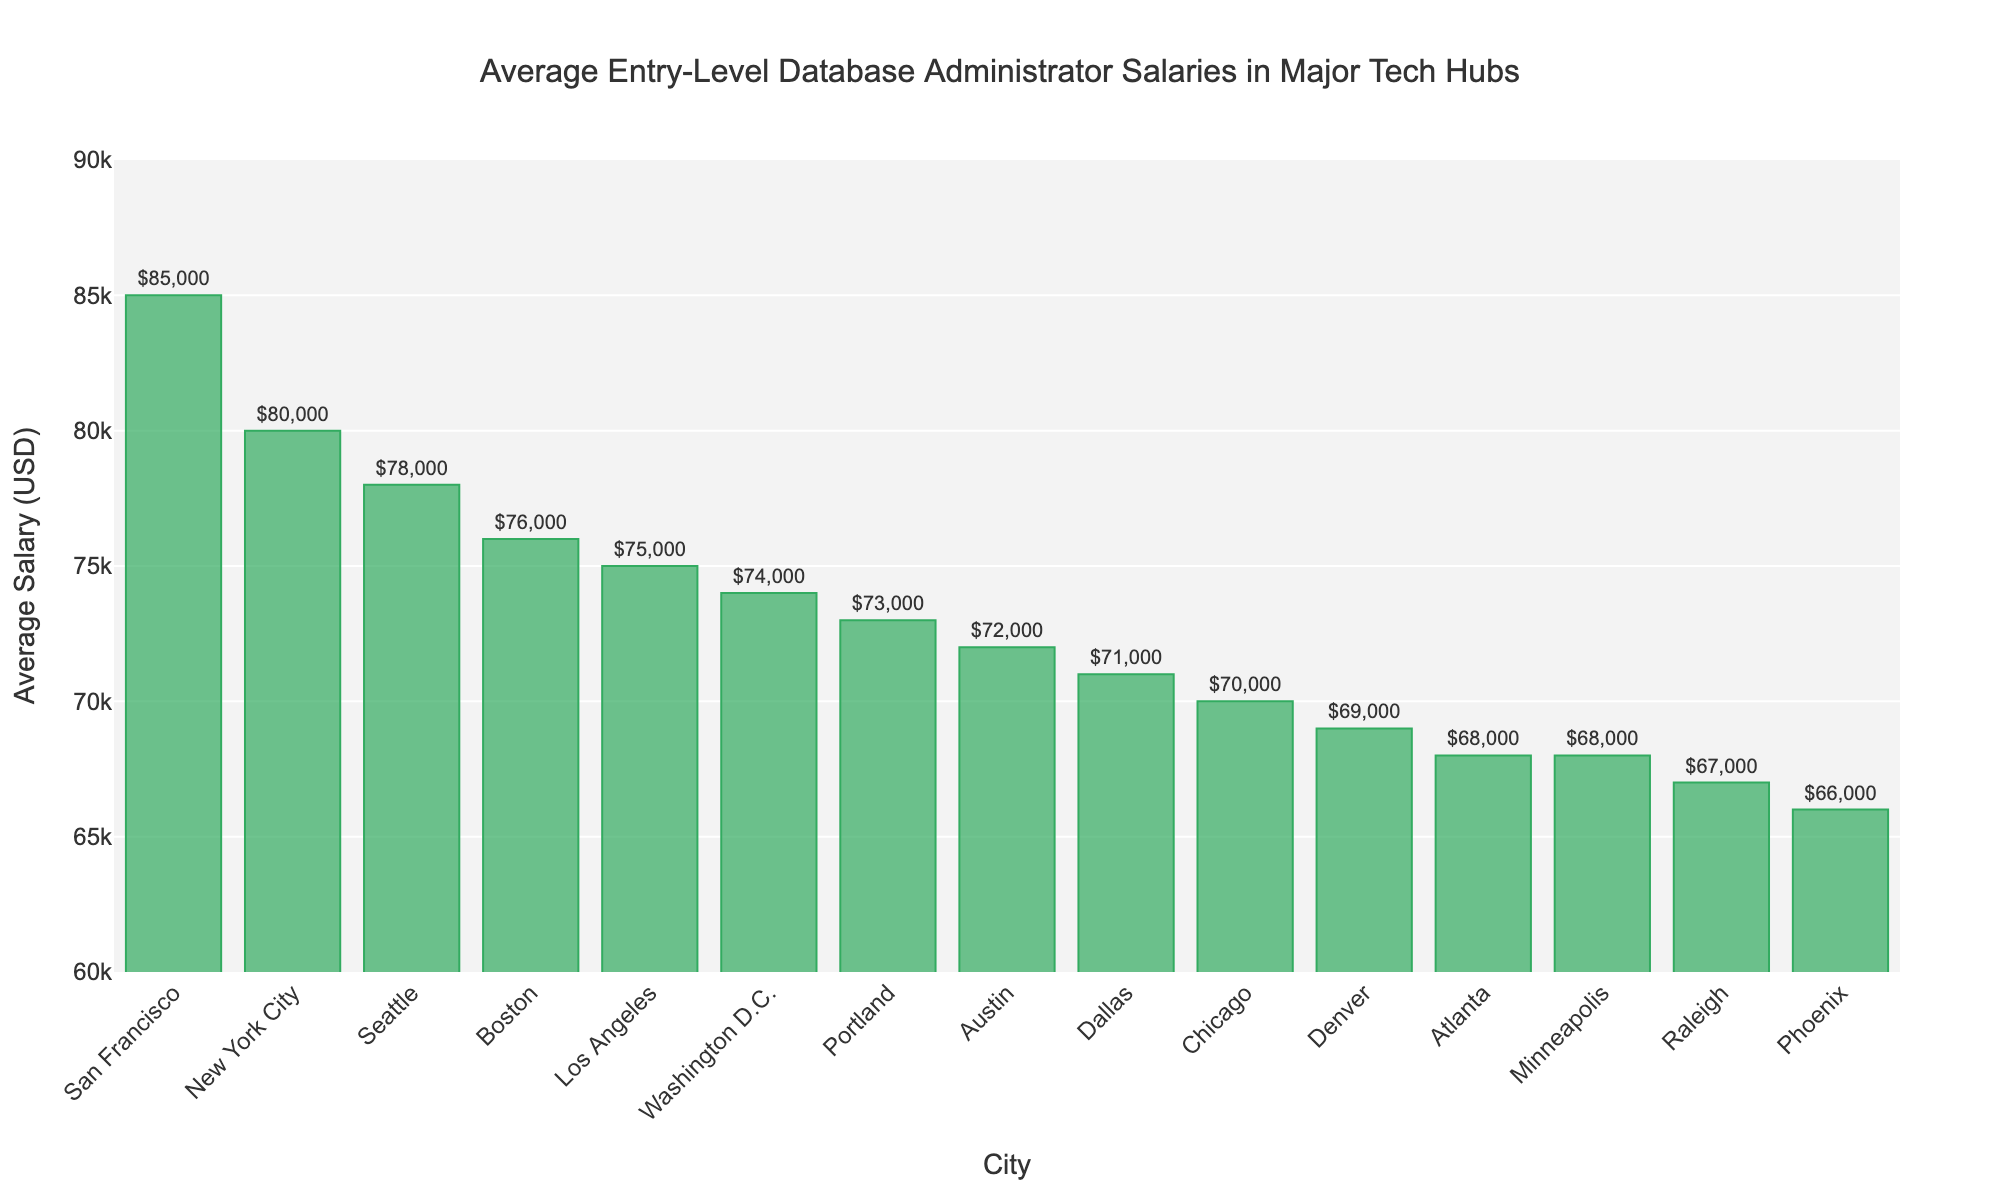Which city has the highest average salary for entry-level database administrators? The figure shows the bar chart with cities on the x-axis and their respective average salaries on the y-axis. The tallest bar corresponds to San Francisco.
Answer: San Francisco Which city has the lowest average salary for entry-level database administrators? The bar at the far right of the chart is the shortest and corresponds to Phoenix, indicating it has the lowest average salary.
Answer: Phoenix How much higher is the average salary in San Francisco compared to Austin? The average salary in San Francisco is $85,000, and in Austin, it is $72,000. The difference is calculated as $85,000 - $72,000.
Answer: $13,000 What is the median average salary among the cities listed? To find the median, sort the salaries in ascending order and select the middle value. The sorted salaries are $66,000, $67,000, $68,000, $68,000, $69,000, $70,000, $71,000, $72,000, $73,000, $74,000, $75,000, $76,000, $78,000, $80,000, $85,000. The middle value is $72,000.
Answer: $72,000 Which city has a higher average salary, Chicago or Washington D.C.? Comparing the heights of the bars for Chicago and Washington D.C., Washington D.C. has a higher average salary ($74,000) than Chicago ($70,000).
Answer: Washington D.C What is the total average salary for New York City, Seattle, and Boston combined? The average salaries are $80,000 (New York City), $78,000 (Seattle), and $76,000 (Boston). Summing these values gives $80,000 + $78,000 + $76,000 = $234,000.
Answer: $234,000 How much lower is the average salary in Dallas compared to New York City? The average salary in Dallas is $71,000, and in New York City, it is $80,000. The difference is $80,000 - $71,000.
Answer: $9,000 Which three cities have the closest average salaries? Observing the bar lengths, Dallas ($71,000), Chicago ($70,000), and Denver ($69,000) are close in average salaries.
Answer: Dallas, Chicago, and Denver What is the range of average salaries shown in the chart? The range is calculated as the difference between the highest and lowest salaries. The highest is $85,000 (San Francisco) and the lowest is $66,000 (Phoenix). The range is $85,000 - $66,000.
Answer: $19,000 